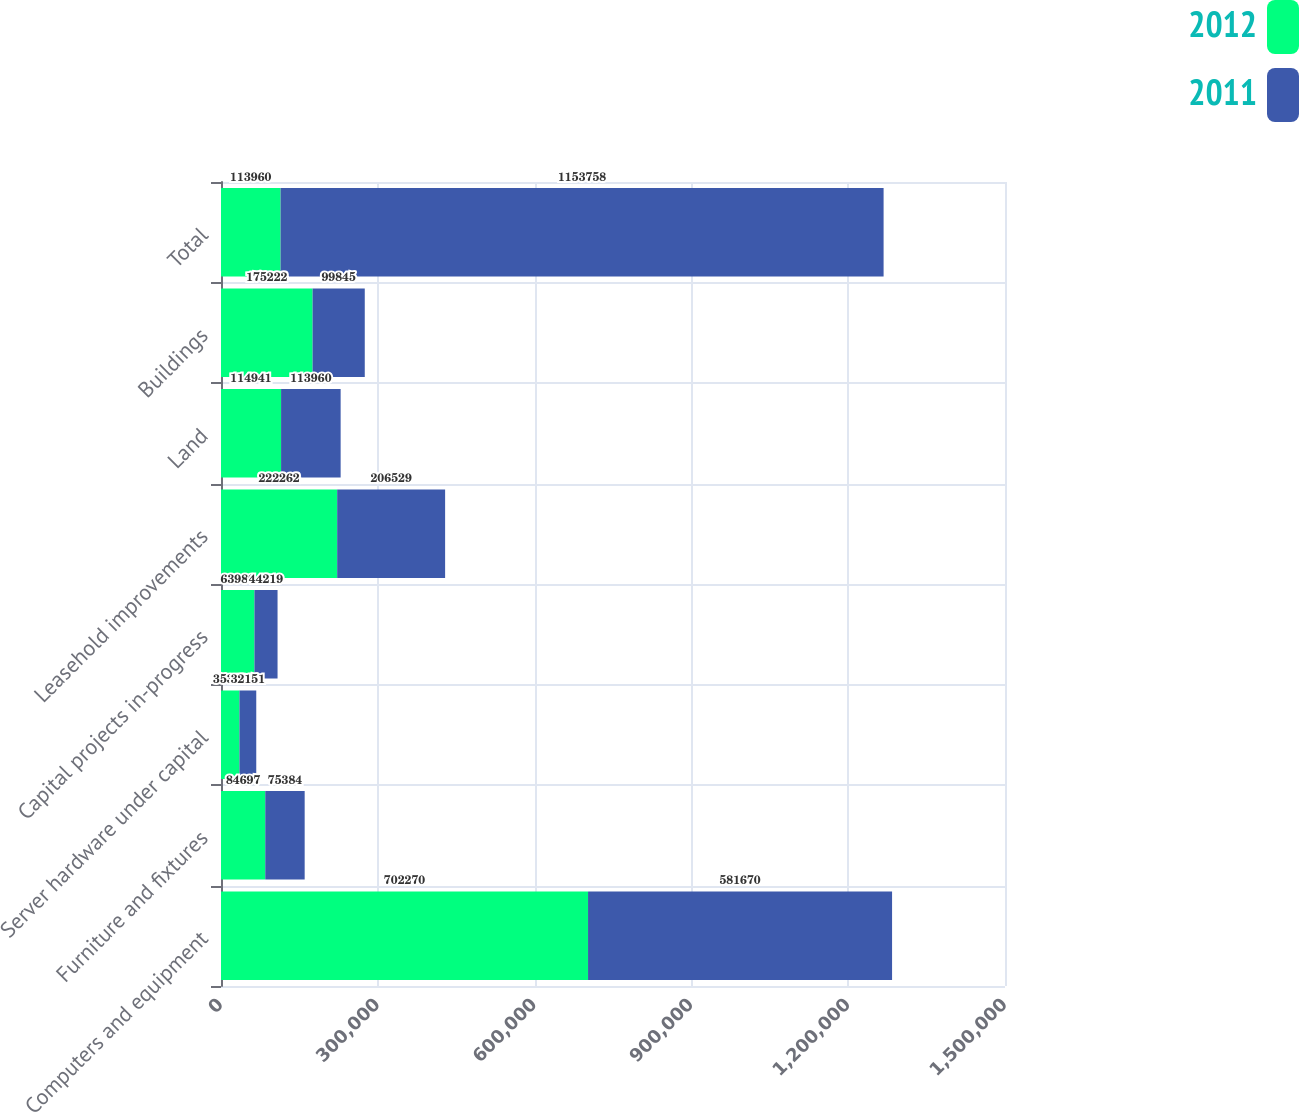<chart> <loc_0><loc_0><loc_500><loc_500><stacked_bar_chart><ecel><fcel>Computers and equipment<fcel>Furniture and fixtures<fcel>Server hardware under capital<fcel>Capital projects in-progress<fcel>Leasehold improvements<fcel>Land<fcel>Buildings<fcel>Total<nl><fcel>2012<fcel>702270<fcel>84697<fcel>35303<fcel>63980<fcel>222262<fcel>114941<fcel>175222<fcel>113960<nl><fcel>2011<fcel>581670<fcel>75384<fcel>32151<fcel>44219<fcel>206529<fcel>113960<fcel>99845<fcel>1.15376e+06<nl></chart> 